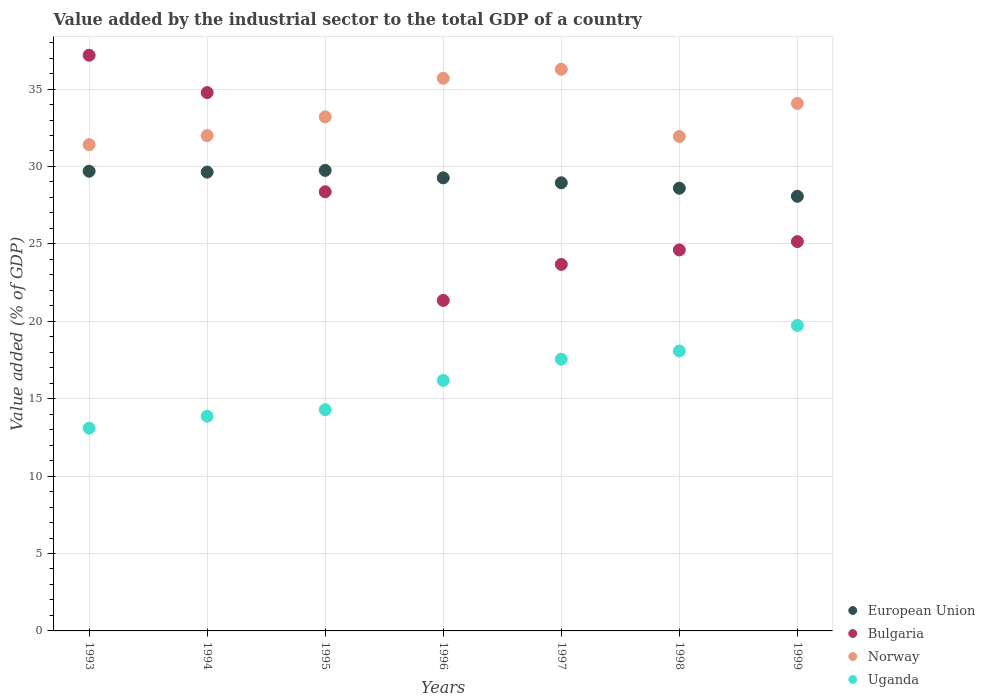What is the value added by the industrial sector to the total GDP in Bulgaria in 1993?
Your answer should be very brief. 37.18. Across all years, what is the maximum value added by the industrial sector to the total GDP in Uganda?
Your response must be concise. 19.73. Across all years, what is the minimum value added by the industrial sector to the total GDP in Bulgaria?
Offer a very short reply. 21.35. In which year was the value added by the industrial sector to the total GDP in Norway maximum?
Your answer should be very brief. 1997. In which year was the value added by the industrial sector to the total GDP in Uganda minimum?
Your answer should be very brief. 1993. What is the total value added by the industrial sector to the total GDP in Norway in the graph?
Your response must be concise. 234.59. What is the difference between the value added by the industrial sector to the total GDP in Norway in 1997 and that in 1999?
Offer a terse response. 2.21. What is the difference between the value added by the industrial sector to the total GDP in Bulgaria in 1998 and the value added by the industrial sector to the total GDP in Norway in 1995?
Provide a succinct answer. -8.6. What is the average value added by the industrial sector to the total GDP in European Union per year?
Your answer should be very brief. 29.14. In the year 1994, what is the difference between the value added by the industrial sector to the total GDP in Bulgaria and value added by the industrial sector to the total GDP in European Union?
Your answer should be compact. 5.14. In how many years, is the value added by the industrial sector to the total GDP in Uganda greater than 29 %?
Ensure brevity in your answer.  0. What is the ratio of the value added by the industrial sector to the total GDP in European Union in 1998 to that in 1999?
Ensure brevity in your answer.  1.02. Is the difference between the value added by the industrial sector to the total GDP in Bulgaria in 1993 and 1994 greater than the difference between the value added by the industrial sector to the total GDP in European Union in 1993 and 1994?
Provide a short and direct response. Yes. What is the difference between the highest and the second highest value added by the industrial sector to the total GDP in Bulgaria?
Your answer should be very brief. 2.41. What is the difference between the highest and the lowest value added by the industrial sector to the total GDP in European Union?
Make the answer very short. 1.67. In how many years, is the value added by the industrial sector to the total GDP in Norway greater than the average value added by the industrial sector to the total GDP in Norway taken over all years?
Your answer should be very brief. 3. Is the sum of the value added by the industrial sector to the total GDP in Norway in 1996 and 1998 greater than the maximum value added by the industrial sector to the total GDP in Bulgaria across all years?
Offer a terse response. Yes. Does the value added by the industrial sector to the total GDP in European Union monotonically increase over the years?
Your answer should be compact. No. Is the value added by the industrial sector to the total GDP in Norway strictly greater than the value added by the industrial sector to the total GDP in European Union over the years?
Keep it short and to the point. Yes. Is the value added by the industrial sector to the total GDP in European Union strictly less than the value added by the industrial sector to the total GDP in Uganda over the years?
Your response must be concise. No. How many dotlines are there?
Offer a very short reply. 4. How many years are there in the graph?
Keep it short and to the point. 7. What is the difference between two consecutive major ticks on the Y-axis?
Keep it short and to the point. 5. Does the graph contain any zero values?
Offer a very short reply. No. Where does the legend appear in the graph?
Offer a very short reply. Bottom right. What is the title of the graph?
Your response must be concise. Value added by the industrial sector to the total GDP of a country. Does "Montenegro" appear as one of the legend labels in the graph?
Your answer should be compact. No. What is the label or title of the Y-axis?
Your response must be concise. Value added (% of GDP). What is the Value added (% of GDP) in European Union in 1993?
Offer a terse response. 29.69. What is the Value added (% of GDP) of Bulgaria in 1993?
Keep it short and to the point. 37.18. What is the Value added (% of GDP) in Norway in 1993?
Offer a very short reply. 31.41. What is the Value added (% of GDP) in Uganda in 1993?
Provide a succinct answer. 13.09. What is the Value added (% of GDP) in European Union in 1994?
Ensure brevity in your answer.  29.64. What is the Value added (% of GDP) of Bulgaria in 1994?
Offer a terse response. 34.77. What is the Value added (% of GDP) of Norway in 1994?
Make the answer very short. 31.99. What is the Value added (% of GDP) of Uganda in 1994?
Offer a very short reply. 13.87. What is the Value added (% of GDP) in European Union in 1995?
Provide a short and direct response. 29.75. What is the Value added (% of GDP) of Bulgaria in 1995?
Provide a succinct answer. 28.37. What is the Value added (% of GDP) of Norway in 1995?
Ensure brevity in your answer.  33.2. What is the Value added (% of GDP) of Uganda in 1995?
Keep it short and to the point. 14.29. What is the Value added (% of GDP) of European Union in 1996?
Your answer should be very brief. 29.26. What is the Value added (% of GDP) in Bulgaria in 1996?
Ensure brevity in your answer.  21.35. What is the Value added (% of GDP) of Norway in 1996?
Your answer should be very brief. 35.7. What is the Value added (% of GDP) in Uganda in 1996?
Your answer should be very brief. 16.18. What is the Value added (% of GDP) in European Union in 1997?
Ensure brevity in your answer.  28.94. What is the Value added (% of GDP) in Bulgaria in 1997?
Your answer should be very brief. 23.67. What is the Value added (% of GDP) of Norway in 1997?
Your answer should be compact. 36.28. What is the Value added (% of GDP) of Uganda in 1997?
Your answer should be compact. 17.55. What is the Value added (% of GDP) in European Union in 1998?
Make the answer very short. 28.6. What is the Value added (% of GDP) of Bulgaria in 1998?
Ensure brevity in your answer.  24.61. What is the Value added (% of GDP) in Norway in 1998?
Offer a terse response. 31.94. What is the Value added (% of GDP) of Uganda in 1998?
Provide a short and direct response. 18.08. What is the Value added (% of GDP) of European Union in 1999?
Keep it short and to the point. 28.07. What is the Value added (% of GDP) of Bulgaria in 1999?
Your answer should be very brief. 25.15. What is the Value added (% of GDP) in Norway in 1999?
Keep it short and to the point. 34.07. What is the Value added (% of GDP) of Uganda in 1999?
Your response must be concise. 19.73. Across all years, what is the maximum Value added (% of GDP) in European Union?
Offer a very short reply. 29.75. Across all years, what is the maximum Value added (% of GDP) in Bulgaria?
Your answer should be compact. 37.18. Across all years, what is the maximum Value added (% of GDP) of Norway?
Provide a succinct answer. 36.28. Across all years, what is the maximum Value added (% of GDP) of Uganda?
Your answer should be compact. 19.73. Across all years, what is the minimum Value added (% of GDP) in European Union?
Keep it short and to the point. 28.07. Across all years, what is the minimum Value added (% of GDP) of Bulgaria?
Your response must be concise. 21.35. Across all years, what is the minimum Value added (% of GDP) in Norway?
Offer a terse response. 31.41. Across all years, what is the minimum Value added (% of GDP) in Uganda?
Provide a succinct answer. 13.09. What is the total Value added (% of GDP) in European Union in the graph?
Your answer should be compact. 203.95. What is the total Value added (% of GDP) in Bulgaria in the graph?
Make the answer very short. 195.09. What is the total Value added (% of GDP) of Norway in the graph?
Your answer should be compact. 234.59. What is the total Value added (% of GDP) in Uganda in the graph?
Keep it short and to the point. 112.79. What is the difference between the Value added (% of GDP) of European Union in 1993 and that in 1994?
Provide a succinct answer. 0.06. What is the difference between the Value added (% of GDP) of Bulgaria in 1993 and that in 1994?
Offer a terse response. 2.41. What is the difference between the Value added (% of GDP) in Norway in 1993 and that in 1994?
Your response must be concise. -0.59. What is the difference between the Value added (% of GDP) of Uganda in 1993 and that in 1994?
Provide a short and direct response. -0.77. What is the difference between the Value added (% of GDP) of European Union in 1993 and that in 1995?
Keep it short and to the point. -0.05. What is the difference between the Value added (% of GDP) of Bulgaria in 1993 and that in 1995?
Make the answer very short. 8.82. What is the difference between the Value added (% of GDP) of Norway in 1993 and that in 1995?
Offer a very short reply. -1.79. What is the difference between the Value added (% of GDP) in Uganda in 1993 and that in 1995?
Your answer should be very brief. -1.2. What is the difference between the Value added (% of GDP) in European Union in 1993 and that in 1996?
Offer a terse response. 0.43. What is the difference between the Value added (% of GDP) of Bulgaria in 1993 and that in 1996?
Provide a short and direct response. 15.84. What is the difference between the Value added (% of GDP) of Norway in 1993 and that in 1996?
Your answer should be very brief. -4.29. What is the difference between the Value added (% of GDP) in Uganda in 1993 and that in 1996?
Provide a succinct answer. -3.09. What is the difference between the Value added (% of GDP) of European Union in 1993 and that in 1997?
Make the answer very short. 0.75. What is the difference between the Value added (% of GDP) in Bulgaria in 1993 and that in 1997?
Keep it short and to the point. 13.51. What is the difference between the Value added (% of GDP) in Norway in 1993 and that in 1997?
Give a very brief answer. -4.87. What is the difference between the Value added (% of GDP) of Uganda in 1993 and that in 1997?
Keep it short and to the point. -4.46. What is the difference between the Value added (% of GDP) of European Union in 1993 and that in 1998?
Offer a very short reply. 1.1. What is the difference between the Value added (% of GDP) in Bulgaria in 1993 and that in 1998?
Provide a short and direct response. 12.58. What is the difference between the Value added (% of GDP) in Norway in 1993 and that in 1998?
Offer a terse response. -0.53. What is the difference between the Value added (% of GDP) of Uganda in 1993 and that in 1998?
Provide a short and direct response. -4.98. What is the difference between the Value added (% of GDP) of European Union in 1993 and that in 1999?
Ensure brevity in your answer.  1.62. What is the difference between the Value added (% of GDP) of Bulgaria in 1993 and that in 1999?
Offer a terse response. 12.04. What is the difference between the Value added (% of GDP) in Norway in 1993 and that in 1999?
Your response must be concise. -2.66. What is the difference between the Value added (% of GDP) of Uganda in 1993 and that in 1999?
Provide a short and direct response. -6.63. What is the difference between the Value added (% of GDP) in European Union in 1994 and that in 1995?
Your answer should be very brief. -0.11. What is the difference between the Value added (% of GDP) of Bulgaria in 1994 and that in 1995?
Keep it short and to the point. 6.41. What is the difference between the Value added (% of GDP) of Norway in 1994 and that in 1995?
Offer a terse response. -1.21. What is the difference between the Value added (% of GDP) in Uganda in 1994 and that in 1995?
Offer a terse response. -0.43. What is the difference between the Value added (% of GDP) of European Union in 1994 and that in 1996?
Provide a succinct answer. 0.37. What is the difference between the Value added (% of GDP) of Bulgaria in 1994 and that in 1996?
Offer a terse response. 13.42. What is the difference between the Value added (% of GDP) of Norway in 1994 and that in 1996?
Keep it short and to the point. -3.7. What is the difference between the Value added (% of GDP) in Uganda in 1994 and that in 1996?
Your response must be concise. -2.31. What is the difference between the Value added (% of GDP) in European Union in 1994 and that in 1997?
Offer a very short reply. 0.69. What is the difference between the Value added (% of GDP) of Bulgaria in 1994 and that in 1997?
Your answer should be compact. 11.1. What is the difference between the Value added (% of GDP) in Norway in 1994 and that in 1997?
Provide a succinct answer. -4.29. What is the difference between the Value added (% of GDP) in Uganda in 1994 and that in 1997?
Ensure brevity in your answer.  -3.69. What is the difference between the Value added (% of GDP) in European Union in 1994 and that in 1998?
Give a very brief answer. 1.04. What is the difference between the Value added (% of GDP) in Bulgaria in 1994 and that in 1998?
Offer a terse response. 10.16. What is the difference between the Value added (% of GDP) in Norway in 1994 and that in 1998?
Make the answer very short. 0.06. What is the difference between the Value added (% of GDP) of Uganda in 1994 and that in 1998?
Provide a succinct answer. -4.21. What is the difference between the Value added (% of GDP) of European Union in 1994 and that in 1999?
Give a very brief answer. 1.56. What is the difference between the Value added (% of GDP) in Bulgaria in 1994 and that in 1999?
Offer a very short reply. 9.63. What is the difference between the Value added (% of GDP) in Norway in 1994 and that in 1999?
Ensure brevity in your answer.  -2.08. What is the difference between the Value added (% of GDP) of Uganda in 1994 and that in 1999?
Your answer should be compact. -5.86. What is the difference between the Value added (% of GDP) of European Union in 1995 and that in 1996?
Give a very brief answer. 0.48. What is the difference between the Value added (% of GDP) of Bulgaria in 1995 and that in 1996?
Give a very brief answer. 7.02. What is the difference between the Value added (% of GDP) of Norway in 1995 and that in 1996?
Your answer should be compact. -2.49. What is the difference between the Value added (% of GDP) of Uganda in 1995 and that in 1996?
Give a very brief answer. -1.89. What is the difference between the Value added (% of GDP) in European Union in 1995 and that in 1997?
Your answer should be compact. 0.8. What is the difference between the Value added (% of GDP) of Bulgaria in 1995 and that in 1997?
Your response must be concise. 4.69. What is the difference between the Value added (% of GDP) in Norway in 1995 and that in 1997?
Offer a very short reply. -3.08. What is the difference between the Value added (% of GDP) of Uganda in 1995 and that in 1997?
Provide a succinct answer. -3.26. What is the difference between the Value added (% of GDP) of European Union in 1995 and that in 1998?
Make the answer very short. 1.15. What is the difference between the Value added (% of GDP) of Bulgaria in 1995 and that in 1998?
Provide a short and direct response. 3.76. What is the difference between the Value added (% of GDP) of Norway in 1995 and that in 1998?
Your answer should be compact. 1.27. What is the difference between the Value added (% of GDP) of Uganda in 1995 and that in 1998?
Your answer should be compact. -3.79. What is the difference between the Value added (% of GDP) in European Union in 1995 and that in 1999?
Your answer should be very brief. 1.67. What is the difference between the Value added (% of GDP) of Bulgaria in 1995 and that in 1999?
Offer a terse response. 3.22. What is the difference between the Value added (% of GDP) of Norway in 1995 and that in 1999?
Offer a very short reply. -0.87. What is the difference between the Value added (% of GDP) of Uganda in 1995 and that in 1999?
Your answer should be very brief. -5.44. What is the difference between the Value added (% of GDP) of European Union in 1996 and that in 1997?
Offer a very short reply. 0.32. What is the difference between the Value added (% of GDP) of Bulgaria in 1996 and that in 1997?
Offer a terse response. -2.32. What is the difference between the Value added (% of GDP) in Norway in 1996 and that in 1997?
Offer a very short reply. -0.58. What is the difference between the Value added (% of GDP) of Uganda in 1996 and that in 1997?
Give a very brief answer. -1.37. What is the difference between the Value added (% of GDP) in European Union in 1996 and that in 1998?
Your response must be concise. 0.67. What is the difference between the Value added (% of GDP) in Bulgaria in 1996 and that in 1998?
Provide a short and direct response. -3.26. What is the difference between the Value added (% of GDP) of Norway in 1996 and that in 1998?
Keep it short and to the point. 3.76. What is the difference between the Value added (% of GDP) in Uganda in 1996 and that in 1998?
Give a very brief answer. -1.9. What is the difference between the Value added (% of GDP) of European Union in 1996 and that in 1999?
Provide a succinct answer. 1.19. What is the difference between the Value added (% of GDP) of Bulgaria in 1996 and that in 1999?
Provide a short and direct response. -3.8. What is the difference between the Value added (% of GDP) of Norway in 1996 and that in 1999?
Ensure brevity in your answer.  1.62. What is the difference between the Value added (% of GDP) in Uganda in 1996 and that in 1999?
Make the answer very short. -3.55. What is the difference between the Value added (% of GDP) in European Union in 1997 and that in 1998?
Provide a succinct answer. 0.35. What is the difference between the Value added (% of GDP) in Bulgaria in 1997 and that in 1998?
Give a very brief answer. -0.94. What is the difference between the Value added (% of GDP) in Norway in 1997 and that in 1998?
Your response must be concise. 4.34. What is the difference between the Value added (% of GDP) of Uganda in 1997 and that in 1998?
Give a very brief answer. -0.53. What is the difference between the Value added (% of GDP) of European Union in 1997 and that in 1999?
Offer a very short reply. 0.87. What is the difference between the Value added (% of GDP) of Bulgaria in 1997 and that in 1999?
Offer a terse response. -1.48. What is the difference between the Value added (% of GDP) in Norway in 1997 and that in 1999?
Ensure brevity in your answer.  2.21. What is the difference between the Value added (% of GDP) of Uganda in 1997 and that in 1999?
Your answer should be compact. -2.18. What is the difference between the Value added (% of GDP) of European Union in 1998 and that in 1999?
Offer a terse response. 0.52. What is the difference between the Value added (% of GDP) in Bulgaria in 1998 and that in 1999?
Your answer should be compact. -0.54. What is the difference between the Value added (% of GDP) in Norway in 1998 and that in 1999?
Your response must be concise. -2.14. What is the difference between the Value added (% of GDP) in Uganda in 1998 and that in 1999?
Ensure brevity in your answer.  -1.65. What is the difference between the Value added (% of GDP) in European Union in 1993 and the Value added (% of GDP) in Bulgaria in 1994?
Offer a terse response. -5.08. What is the difference between the Value added (% of GDP) of European Union in 1993 and the Value added (% of GDP) of Norway in 1994?
Make the answer very short. -2.3. What is the difference between the Value added (% of GDP) in European Union in 1993 and the Value added (% of GDP) in Uganda in 1994?
Provide a succinct answer. 15.83. What is the difference between the Value added (% of GDP) in Bulgaria in 1993 and the Value added (% of GDP) in Norway in 1994?
Provide a short and direct response. 5.19. What is the difference between the Value added (% of GDP) in Bulgaria in 1993 and the Value added (% of GDP) in Uganda in 1994?
Keep it short and to the point. 23.32. What is the difference between the Value added (% of GDP) in Norway in 1993 and the Value added (% of GDP) in Uganda in 1994?
Keep it short and to the point. 17.54. What is the difference between the Value added (% of GDP) of European Union in 1993 and the Value added (% of GDP) of Bulgaria in 1995?
Offer a very short reply. 1.33. What is the difference between the Value added (% of GDP) in European Union in 1993 and the Value added (% of GDP) in Norway in 1995?
Your answer should be compact. -3.51. What is the difference between the Value added (% of GDP) in European Union in 1993 and the Value added (% of GDP) in Uganda in 1995?
Your answer should be very brief. 15.4. What is the difference between the Value added (% of GDP) of Bulgaria in 1993 and the Value added (% of GDP) of Norway in 1995?
Your answer should be compact. 3.98. What is the difference between the Value added (% of GDP) in Bulgaria in 1993 and the Value added (% of GDP) in Uganda in 1995?
Keep it short and to the point. 22.89. What is the difference between the Value added (% of GDP) of Norway in 1993 and the Value added (% of GDP) of Uganda in 1995?
Ensure brevity in your answer.  17.12. What is the difference between the Value added (% of GDP) in European Union in 1993 and the Value added (% of GDP) in Bulgaria in 1996?
Your answer should be very brief. 8.35. What is the difference between the Value added (% of GDP) of European Union in 1993 and the Value added (% of GDP) of Norway in 1996?
Offer a terse response. -6. What is the difference between the Value added (% of GDP) in European Union in 1993 and the Value added (% of GDP) in Uganda in 1996?
Offer a terse response. 13.51. What is the difference between the Value added (% of GDP) of Bulgaria in 1993 and the Value added (% of GDP) of Norway in 1996?
Ensure brevity in your answer.  1.49. What is the difference between the Value added (% of GDP) in Bulgaria in 1993 and the Value added (% of GDP) in Uganda in 1996?
Your answer should be very brief. 21. What is the difference between the Value added (% of GDP) in Norway in 1993 and the Value added (% of GDP) in Uganda in 1996?
Your answer should be very brief. 15.23. What is the difference between the Value added (% of GDP) in European Union in 1993 and the Value added (% of GDP) in Bulgaria in 1997?
Provide a succinct answer. 6.02. What is the difference between the Value added (% of GDP) in European Union in 1993 and the Value added (% of GDP) in Norway in 1997?
Provide a short and direct response. -6.59. What is the difference between the Value added (% of GDP) in European Union in 1993 and the Value added (% of GDP) in Uganda in 1997?
Give a very brief answer. 12.14. What is the difference between the Value added (% of GDP) in Bulgaria in 1993 and the Value added (% of GDP) in Norway in 1997?
Your response must be concise. 0.9. What is the difference between the Value added (% of GDP) of Bulgaria in 1993 and the Value added (% of GDP) of Uganda in 1997?
Your response must be concise. 19.63. What is the difference between the Value added (% of GDP) in Norway in 1993 and the Value added (% of GDP) in Uganda in 1997?
Make the answer very short. 13.86. What is the difference between the Value added (% of GDP) of European Union in 1993 and the Value added (% of GDP) of Bulgaria in 1998?
Keep it short and to the point. 5.09. What is the difference between the Value added (% of GDP) of European Union in 1993 and the Value added (% of GDP) of Norway in 1998?
Your answer should be very brief. -2.24. What is the difference between the Value added (% of GDP) in European Union in 1993 and the Value added (% of GDP) in Uganda in 1998?
Your answer should be very brief. 11.61. What is the difference between the Value added (% of GDP) of Bulgaria in 1993 and the Value added (% of GDP) of Norway in 1998?
Your answer should be very brief. 5.25. What is the difference between the Value added (% of GDP) in Bulgaria in 1993 and the Value added (% of GDP) in Uganda in 1998?
Your answer should be compact. 19.1. What is the difference between the Value added (% of GDP) in Norway in 1993 and the Value added (% of GDP) in Uganda in 1998?
Provide a short and direct response. 13.33. What is the difference between the Value added (% of GDP) of European Union in 1993 and the Value added (% of GDP) of Bulgaria in 1999?
Your answer should be very brief. 4.55. What is the difference between the Value added (% of GDP) in European Union in 1993 and the Value added (% of GDP) in Norway in 1999?
Ensure brevity in your answer.  -4.38. What is the difference between the Value added (% of GDP) in European Union in 1993 and the Value added (% of GDP) in Uganda in 1999?
Your answer should be compact. 9.96. What is the difference between the Value added (% of GDP) in Bulgaria in 1993 and the Value added (% of GDP) in Norway in 1999?
Keep it short and to the point. 3.11. What is the difference between the Value added (% of GDP) of Bulgaria in 1993 and the Value added (% of GDP) of Uganda in 1999?
Your answer should be very brief. 17.45. What is the difference between the Value added (% of GDP) in Norway in 1993 and the Value added (% of GDP) in Uganda in 1999?
Offer a terse response. 11.68. What is the difference between the Value added (% of GDP) of European Union in 1994 and the Value added (% of GDP) of Bulgaria in 1995?
Make the answer very short. 1.27. What is the difference between the Value added (% of GDP) of European Union in 1994 and the Value added (% of GDP) of Norway in 1995?
Offer a very short reply. -3.57. What is the difference between the Value added (% of GDP) in European Union in 1994 and the Value added (% of GDP) in Uganda in 1995?
Your answer should be very brief. 15.34. What is the difference between the Value added (% of GDP) in Bulgaria in 1994 and the Value added (% of GDP) in Norway in 1995?
Your response must be concise. 1.57. What is the difference between the Value added (% of GDP) in Bulgaria in 1994 and the Value added (% of GDP) in Uganda in 1995?
Offer a terse response. 20.48. What is the difference between the Value added (% of GDP) in Norway in 1994 and the Value added (% of GDP) in Uganda in 1995?
Your answer should be compact. 17.7. What is the difference between the Value added (% of GDP) of European Union in 1994 and the Value added (% of GDP) of Bulgaria in 1996?
Ensure brevity in your answer.  8.29. What is the difference between the Value added (% of GDP) in European Union in 1994 and the Value added (% of GDP) in Norway in 1996?
Make the answer very short. -6.06. What is the difference between the Value added (% of GDP) in European Union in 1994 and the Value added (% of GDP) in Uganda in 1996?
Provide a succinct answer. 13.46. What is the difference between the Value added (% of GDP) in Bulgaria in 1994 and the Value added (% of GDP) in Norway in 1996?
Provide a succinct answer. -0.92. What is the difference between the Value added (% of GDP) of Bulgaria in 1994 and the Value added (% of GDP) of Uganda in 1996?
Ensure brevity in your answer.  18.59. What is the difference between the Value added (% of GDP) in Norway in 1994 and the Value added (% of GDP) in Uganda in 1996?
Offer a very short reply. 15.81. What is the difference between the Value added (% of GDP) of European Union in 1994 and the Value added (% of GDP) of Bulgaria in 1997?
Provide a succinct answer. 5.96. What is the difference between the Value added (% of GDP) in European Union in 1994 and the Value added (% of GDP) in Norway in 1997?
Offer a very short reply. -6.64. What is the difference between the Value added (% of GDP) of European Union in 1994 and the Value added (% of GDP) of Uganda in 1997?
Make the answer very short. 12.08. What is the difference between the Value added (% of GDP) of Bulgaria in 1994 and the Value added (% of GDP) of Norway in 1997?
Keep it short and to the point. -1.51. What is the difference between the Value added (% of GDP) in Bulgaria in 1994 and the Value added (% of GDP) in Uganda in 1997?
Your answer should be compact. 17.22. What is the difference between the Value added (% of GDP) in Norway in 1994 and the Value added (% of GDP) in Uganda in 1997?
Provide a short and direct response. 14.44. What is the difference between the Value added (% of GDP) in European Union in 1994 and the Value added (% of GDP) in Bulgaria in 1998?
Keep it short and to the point. 5.03. What is the difference between the Value added (% of GDP) of European Union in 1994 and the Value added (% of GDP) of Norway in 1998?
Ensure brevity in your answer.  -2.3. What is the difference between the Value added (% of GDP) in European Union in 1994 and the Value added (% of GDP) in Uganda in 1998?
Your response must be concise. 11.56. What is the difference between the Value added (% of GDP) of Bulgaria in 1994 and the Value added (% of GDP) of Norway in 1998?
Your answer should be compact. 2.84. What is the difference between the Value added (% of GDP) of Bulgaria in 1994 and the Value added (% of GDP) of Uganda in 1998?
Your answer should be compact. 16.69. What is the difference between the Value added (% of GDP) of Norway in 1994 and the Value added (% of GDP) of Uganda in 1998?
Provide a short and direct response. 13.91. What is the difference between the Value added (% of GDP) of European Union in 1994 and the Value added (% of GDP) of Bulgaria in 1999?
Keep it short and to the point. 4.49. What is the difference between the Value added (% of GDP) in European Union in 1994 and the Value added (% of GDP) in Norway in 1999?
Make the answer very short. -4.43. What is the difference between the Value added (% of GDP) in European Union in 1994 and the Value added (% of GDP) in Uganda in 1999?
Provide a succinct answer. 9.91. What is the difference between the Value added (% of GDP) of Bulgaria in 1994 and the Value added (% of GDP) of Norway in 1999?
Your answer should be very brief. 0.7. What is the difference between the Value added (% of GDP) of Bulgaria in 1994 and the Value added (% of GDP) of Uganda in 1999?
Offer a terse response. 15.04. What is the difference between the Value added (% of GDP) of Norway in 1994 and the Value added (% of GDP) of Uganda in 1999?
Provide a short and direct response. 12.26. What is the difference between the Value added (% of GDP) in European Union in 1995 and the Value added (% of GDP) in Bulgaria in 1996?
Offer a terse response. 8.4. What is the difference between the Value added (% of GDP) of European Union in 1995 and the Value added (% of GDP) of Norway in 1996?
Ensure brevity in your answer.  -5.95. What is the difference between the Value added (% of GDP) in European Union in 1995 and the Value added (% of GDP) in Uganda in 1996?
Ensure brevity in your answer.  13.56. What is the difference between the Value added (% of GDP) in Bulgaria in 1995 and the Value added (% of GDP) in Norway in 1996?
Keep it short and to the point. -7.33. What is the difference between the Value added (% of GDP) in Bulgaria in 1995 and the Value added (% of GDP) in Uganda in 1996?
Offer a terse response. 12.18. What is the difference between the Value added (% of GDP) in Norway in 1995 and the Value added (% of GDP) in Uganda in 1996?
Provide a succinct answer. 17.02. What is the difference between the Value added (% of GDP) of European Union in 1995 and the Value added (% of GDP) of Bulgaria in 1997?
Provide a short and direct response. 6.07. What is the difference between the Value added (% of GDP) in European Union in 1995 and the Value added (% of GDP) in Norway in 1997?
Your response must be concise. -6.54. What is the difference between the Value added (% of GDP) of European Union in 1995 and the Value added (% of GDP) of Uganda in 1997?
Give a very brief answer. 12.19. What is the difference between the Value added (% of GDP) in Bulgaria in 1995 and the Value added (% of GDP) in Norway in 1997?
Keep it short and to the point. -7.92. What is the difference between the Value added (% of GDP) of Bulgaria in 1995 and the Value added (% of GDP) of Uganda in 1997?
Your answer should be compact. 10.81. What is the difference between the Value added (% of GDP) of Norway in 1995 and the Value added (% of GDP) of Uganda in 1997?
Ensure brevity in your answer.  15.65. What is the difference between the Value added (% of GDP) in European Union in 1995 and the Value added (% of GDP) in Bulgaria in 1998?
Offer a very short reply. 5.14. What is the difference between the Value added (% of GDP) of European Union in 1995 and the Value added (% of GDP) of Norway in 1998?
Keep it short and to the point. -2.19. What is the difference between the Value added (% of GDP) of European Union in 1995 and the Value added (% of GDP) of Uganda in 1998?
Keep it short and to the point. 11.67. What is the difference between the Value added (% of GDP) in Bulgaria in 1995 and the Value added (% of GDP) in Norway in 1998?
Ensure brevity in your answer.  -3.57. What is the difference between the Value added (% of GDP) of Bulgaria in 1995 and the Value added (% of GDP) of Uganda in 1998?
Provide a short and direct response. 10.29. What is the difference between the Value added (% of GDP) in Norway in 1995 and the Value added (% of GDP) in Uganda in 1998?
Your answer should be very brief. 15.12. What is the difference between the Value added (% of GDP) in European Union in 1995 and the Value added (% of GDP) in Bulgaria in 1999?
Provide a short and direct response. 4.6. What is the difference between the Value added (% of GDP) in European Union in 1995 and the Value added (% of GDP) in Norway in 1999?
Offer a very short reply. -4.33. What is the difference between the Value added (% of GDP) in European Union in 1995 and the Value added (% of GDP) in Uganda in 1999?
Make the answer very short. 10.02. What is the difference between the Value added (% of GDP) of Bulgaria in 1995 and the Value added (% of GDP) of Norway in 1999?
Give a very brief answer. -5.71. What is the difference between the Value added (% of GDP) of Bulgaria in 1995 and the Value added (% of GDP) of Uganda in 1999?
Give a very brief answer. 8.64. What is the difference between the Value added (% of GDP) in Norway in 1995 and the Value added (% of GDP) in Uganda in 1999?
Offer a terse response. 13.47. What is the difference between the Value added (% of GDP) in European Union in 1996 and the Value added (% of GDP) in Bulgaria in 1997?
Provide a succinct answer. 5.59. What is the difference between the Value added (% of GDP) in European Union in 1996 and the Value added (% of GDP) in Norway in 1997?
Provide a succinct answer. -7.02. What is the difference between the Value added (% of GDP) in European Union in 1996 and the Value added (% of GDP) in Uganda in 1997?
Your answer should be very brief. 11.71. What is the difference between the Value added (% of GDP) in Bulgaria in 1996 and the Value added (% of GDP) in Norway in 1997?
Your answer should be compact. -14.93. What is the difference between the Value added (% of GDP) in Bulgaria in 1996 and the Value added (% of GDP) in Uganda in 1997?
Your answer should be very brief. 3.8. What is the difference between the Value added (% of GDP) of Norway in 1996 and the Value added (% of GDP) of Uganda in 1997?
Your answer should be compact. 18.14. What is the difference between the Value added (% of GDP) in European Union in 1996 and the Value added (% of GDP) in Bulgaria in 1998?
Provide a succinct answer. 4.66. What is the difference between the Value added (% of GDP) of European Union in 1996 and the Value added (% of GDP) of Norway in 1998?
Your response must be concise. -2.67. What is the difference between the Value added (% of GDP) in European Union in 1996 and the Value added (% of GDP) in Uganda in 1998?
Your answer should be compact. 11.18. What is the difference between the Value added (% of GDP) of Bulgaria in 1996 and the Value added (% of GDP) of Norway in 1998?
Keep it short and to the point. -10.59. What is the difference between the Value added (% of GDP) of Bulgaria in 1996 and the Value added (% of GDP) of Uganda in 1998?
Make the answer very short. 3.27. What is the difference between the Value added (% of GDP) in Norway in 1996 and the Value added (% of GDP) in Uganda in 1998?
Ensure brevity in your answer.  17.62. What is the difference between the Value added (% of GDP) in European Union in 1996 and the Value added (% of GDP) in Bulgaria in 1999?
Give a very brief answer. 4.12. What is the difference between the Value added (% of GDP) in European Union in 1996 and the Value added (% of GDP) in Norway in 1999?
Your answer should be compact. -4.81. What is the difference between the Value added (% of GDP) in European Union in 1996 and the Value added (% of GDP) in Uganda in 1999?
Make the answer very short. 9.53. What is the difference between the Value added (% of GDP) of Bulgaria in 1996 and the Value added (% of GDP) of Norway in 1999?
Your answer should be very brief. -12.72. What is the difference between the Value added (% of GDP) in Bulgaria in 1996 and the Value added (% of GDP) in Uganda in 1999?
Provide a short and direct response. 1.62. What is the difference between the Value added (% of GDP) of Norway in 1996 and the Value added (% of GDP) of Uganda in 1999?
Your answer should be very brief. 15.97. What is the difference between the Value added (% of GDP) in European Union in 1997 and the Value added (% of GDP) in Bulgaria in 1998?
Your answer should be very brief. 4.34. What is the difference between the Value added (% of GDP) in European Union in 1997 and the Value added (% of GDP) in Norway in 1998?
Ensure brevity in your answer.  -2.99. What is the difference between the Value added (% of GDP) in European Union in 1997 and the Value added (% of GDP) in Uganda in 1998?
Keep it short and to the point. 10.87. What is the difference between the Value added (% of GDP) in Bulgaria in 1997 and the Value added (% of GDP) in Norway in 1998?
Offer a terse response. -8.26. What is the difference between the Value added (% of GDP) in Bulgaria in 1997 and the Value added (% of GDP) in Uganda in 1998?
Provide a short and direct response. 5.59. What is the difference between the Value added (% of GDP) of Norway in 1997 and the Value added (% of GDP) of Uganda in 1998?
Your answer should be compact. 18.2. What is the difference between the Value added (% of GDP) of European Union in 1997 and the Value added (% of GDP) of Bulgaria in 1999?
Provide a short and direct response. 3.8. What is the difference between the Value added (% of GDP) in European Union in 1997 and the Value added (% of GDP) in Norway in 1999?
Give a very brief answer. -5.13. What is the difference between the Value added (% of GDP) in European Union in 1997 and the Value added (% of GDP) in Uganda in 1999?
Provide a short and direct response. 9.21. What is the difference between the Value added (% of GDP) of Bulgaria in 1997 and the Value added (% of GDP) of Norway in 1999?
Ensure brevity in your answer.  -10.4. What is the difference between the Value added (% of GDP) of Bulgaria in 1997 and the Value added (% of GDP) of Uganda in 1999?
Your answer should be compact. 3.94. What is the difference between the Value added (% of GDP) of Norway in 1997 and the Value added (% of GDP) of Uganda in 1999?
Give a very brief answer. 16.55. What is the difference between the Value added (% of GDP) of European Union in 1998 and the Value added (% of GDP) of Bulgaria in 1999?
Provide a short and direct response. 3.45. What is the difference between the Value added (% of GDP) of European Union in 1998 and the Value added (% of GDP) of Norway in 1999?
Your answer should be very brief. -5.48. What is the difference between the Value added (% of GDP) of European Union in 1998 and the Value added (% of GDP) of Uganda in 1999?
Provide a short and direct response. 8.87. What is the difference between the Value added (% of GDP) of Bulgaria in 1998 and the Value added (% of GDP) of Norway in 1999?
Ensure brevity in your answer.  -9.46. What is the difference between the Value added (% of GDP) in Bulgaria in 1998 and the Value added (% of GDP) in Uganda in 1999?
Provide a succinct answer. 4.88. What is the difference between the Value added (% of GDP) of Norway in 1998 and the Value added (% of GDP) of Uganda in 1999?
Offer a terse response. 12.21. What is the average Value added (% of GDP) of European Union per year?
Make the answer very short. 29.14. What is the average Value added (% of GDP) of Bulgaria per year?
Offer a terse response. 27.87. What is the average Value added (% of GDP) of Norway per year?
Provide a succinct answer. 33.51. What is the average Value added (% of GDP) in Uganda per year?
Your answer should be compact. 16.11. In the year 1993, what is the difference between the Value added (% of GDP) in European Union and Value added (% of GDP) in Bulgaria?
Provide a succinct answer. -7.49. In the year 1993, what is the difference between the Value added (% of GDP) in European Union and Value added (% of GDP) in Norway?
Offer a very short reply. -1.72. In the year 1993, what is the difference between the Value added (% of GDP) in European Union and Value added (% of GDP) in Uganda?
Keep it short and to the point. 16.6. In the year 1993, what is the difference between the Value added (% of GDP) of Bulgaria and Value added (% of GDP) of Norway?
Provide a short and direct response. 5.78. In the year 1993, what is the difference between the Value added (% of GDP) in Bulgaria and Value added (% of GDP) in Uganda?
Offer a terse response. 24.09. In the year 1993, what is the difference between the Value added (% of GDP) in Norway and Value added (% of GDP) in Uganda?
Your response must be concise. 18.31. In the year 1994, what is the difference between the Value added (% of GDP) of European Union and Value added (% of GDP) of Bulgaria?
Your answer should be compact. -5.14. In the year 1994, what is the difference between the Value added (% of GDP) of European Union and Value added (% of GDP) of Norway?
Keep it short and to the point. -2.36. In the year 1994, what is the difference between the Value added (% of GDP) in European Union and Value added (% of GDP) in Uganda?
Offer a terse response. 15.77. In the year 1994, what is the difference between the Value added (% of GDP) in Bulgaria and Value added (% of GDP) in Norway?
Make the answer very short. 2.78. In the year 1994, what is the difference between the Value added (% of GDP) of Bulgaria and Value added (% of GDP) of Uganda?
Make the answer very short. 20.91. In the year 1994, what is the difference between the Value added (% of GDP) in Norway and Value added (% of GDP) in Uganda?
Your response must be concise. 18.13. In the year 1995, what is the difference between the Value added (% of GDP) in European Union and Value added (% of GDP) in Bulgaria?
Your response must be concise. 1.38. In the year 1995, what is the difference between the Value added (% of GDP) in European Union and Value added (% of GDP) in Norway?
Offer a terse response. -3.46. In the year 1995, what is the difference between the Value added (% of GDP) in European Union and Value added (% of GDP) in Uganda?
Offer a very short reply. 15.45. In the year 1995, what is the difference between the Value added (% of GDP) of Bulgaria and Value added (% of GDP) of Norway?
Provide a short and direct response. -4.84. In the year 1995, what is the difference between the Value added (% of GDP) of Bulgaria and Value added (% of GDP) of Uganda?
Ensure brevity in your answer.  14.07. In the year 1995, what is the difference between the Value added (% of GDP) of Norway and Value added (% of GDP) of Uganda?
Provide a short and direct response. 18.91. In the year 1996, what is the difference between the Value added (% of GDP) in European Union and Value added (% of GDP) in Bulgaria?
Ensure brevity in your answer.  7.92. In the year 1996, what is the difference between the Value added (% of GDP) of European Union and Value added (% of GDP) of Norway?
Offer a very short reply. -6.43. In the year 1996, what is the difference between the Value added (% of GDP) in European Union and Value added (% of GDP) in Uganda?
Offer a terse response. 13.08. In the year 1996, what is the difference between the Value added (% of GDP) of Bulgaria and Value added (% of GDP) of Norway?
Your answer should be very brief. -14.35. In the year 1996, what is the difference between the Value added (% of GDP) of Bulgaria and Value added (% of GDP) of Uganda?
Provide a short and direct response. 5.17. In the year 1996, what is the difference between the Value added (% of GDP) in Norway and Value added (% of GDP) in Uganda?
Provide a succinct answer. 19.51. In the year 1997, what is the difference between the Value added (% of GDP) of European Union and Value added (% of GDP) of Bulgaria?
Provide a short and direct response. 5.27. In the year 1997, what is the difference between the Value added (% of GDP) in European Union and Value added (% of GDP) in Norway?
Offer a very short reply. -7.34. In the year 1997, what is the difference between the Value added (% of GDP) of European Union and Value added (% of GDP) of Uganda?
Give a very brief answer. 11.39. In the year 1997, what is the difference between the Value added (% of GDP) in Bulgaria and Value added (% of GDP) in Norway?
Offer a very short reply. -12.61. In the year 1997, what is the difference between the Value added (% of GDP) in Bulgaria and Value added (% of GDP) in Uganda?
Provide a short and direct response. 6.12. In the year 1997, what is the difference between the Value added (% of GDP) in Norway and Value added (% of GDP) in Uganda?
Make the answer very short. 18.73. In the year 1998, what is the difference between the Value added (% of GDP) of European Union and Value added (% of GDP) of Bulgaria?
Your answer should be compact. 3.99. In the year 1998, what is the difference between the Value added (% of GDP) of European Union and Value added (% of GDP) of Norway?
Your response must be concise. -3.34. In the year 1998, what is the difference between the Value added (% of GDP) in European Union and Value added (% of GDP) in Uganda?
Make the answer very short. 10.52. In the year 1998, what is the difference between the Value added (% of GDP) of Bulgaria and Value added (% of GDP) of Norway?
Your response must be concise. -7.33. In the year 1998, what is the difference between the Value added (% of GDP) in Bulgaria and Value added (% of GDP) in Uganda?
Give a very brief answer. 6.53. In the year 1998, what is the difference between the Value added (% of GDP) in Norway and Value added (% of GDP) in Uganda?
Offer a terse response. 13.86. In the year 1999, what is the difference between the Value added (% of GDP) of European Union and Value added (% of GDP) of Bulgaria?
Offer a very short reply. 2.93. In the year 1999, what is the difference between the Value added (% of GDP) in European Union and Value added (% of GDP) in Norway?
Keep it short and to the point. -6. In the year 1999, what is the difference between the Value added (% of GDP) of European Union and Value added (% of GDP) of Uganda?
Keep it short and to the point. 8.34. In the year 1999, what is the difference between the Value added (% of GDP) in Bulgaria and Value added (% of GDP) in Norway?
Ensure brevity in your answer.  -8.92. In the year 1999, what is the difference between the Value added (% of GDP) in Bulgaria and Value added (% of GDP) in Uganda?
Make the answer very short. 5.42. In the year 1999, what is the difference between the Value added (% of GDP) in Norway and Value added (% of GDP) in Uganda?
Your answer should be very brief. 14.34. What is the ratio of the Value added (% of GDP) of European Union in 1993 to that in 1994?
Make the answer very short. 1. What is the ratio of the Value added (% of GDP) in Bulgaria in 1993 to that in 1994?
Your answer should be compact. 1.07. What is the ratio of the Value added (% of GDP) in Norway in 1993 to that in 1994?
Ensure brevity in your answer.  0.98. What is the ratio of the Value added (% of GDP) in Uganda in 1993 to that in 1994?
Give a very brief answer. 0.94. What is the ratio of the Value added (% of GDP) in Bulgaria in 1993 to that in 1995?
Your answer should be very brief. 1.31. What is the ratio of the Value added (% of GDP) of Norway in 1993 to that in 1995?
Offer a very short reply. 0.95. What is the ratio of the Value added (% of GDP) in Uganda in 1993 to that in 1995?
Give a very brief answer. 0.92. What is the ratio of the Value added (% of GDP) of European Union in 1993 to that in 1996?
Make the answer very short. 1.01. What is the ratio of the Value added (% of GDP) in Bulgaria in 1993 to that in 1996?
Offer a very short reply. 1.74. What is the ratio of the Value added (% of GDP) of Norway in 1993 to that in 1996?
Your answer should be compact. 0.88. What is the ratio of the Value added (% of GDP) in Uganda in 1993 to that in 1996?
Provide a succinct answer. 0.81. What is the ratio of the Value added (% of GDP) in European Union in 1993 to that in 1997?
Your answer should be compact. 1.03. What is the ratio of the Value added (% of GDP) in Bulgaria in 1993 to that in 1997?
Give a very brief answer. 1.57. What is the ratio of the Value added (% of GDP) in Norway in 1993 to that in 1997?
Make the answer very short. 0.87. What is the ratio of the Value added (% of GDP) of Uganda in 1993 to that in 1997?
Your answer should be very brief. 0.75. What is the ratio of the Value added (% of GDP) in European Union in 1993 to that in 1998?
Provide a short and direct response. 1.04. What is the ratio of the Value added (% of GDP) in Bulgaria in 1993 to that in 1998?
Provide a short and direct response. 1.51. What is the ratio of the Value added (% of GDP) of Norway in 1993 to that in 1998?
Ensure brevity in your answer.  0.98. What is the ratio of the Value added (% of GDP) in Uganda in 1993 to that in 1998?
Ensure brevity in your answer.  0.72. What is the ratio of the Value added (% of GDP) in European Union in 1993 to that in 1999?
Offer a very short reply. 1.06. What is the ratio of the Value added (% of GDP) in Bulgaria in 1993 to that in 1999?
Give a very brief answer. 1.48. What is the ratio of the Value added (% of GDP) in Norway in 1993 to that in 1999?
Your response must be concise. 0.92. What is the ratio of the Value added (% of GDP) in Uganda in 1993 to that in 1999?
Your answer should be very brief. 0.66. What is the ratio of the Value added (% of GDP) in Bulgaria in 1994 to that in 1995?
Ensure brevity in your answer.  1.23. What is the ratio of the Value added (% of GDP) in Norway in 1994 to that in 1995?
Make the answer very short. 0.96. What is the ratio of the Value added (% of GDP) in Uganda in 1994 to that in 1995?
Offer a very short reply. 0.97. What is the ratio of the Value added (% of GDP) in European Union in 1994 to that in 1996?
Your response must be concise. 1.01. What is the ratio of the Value added (% of GDP) in Bulgaria in 1994 to that in 1996?
Offer a terse response. 1.63. What is the ratio of the Value added (% of GDP) in Norway in 1994 to that in 1996?
Your answer should be compact. 0.9. What is the ratio of the Value added (% of GDP) of Uganda in 1994 to that in 1996?
Your answer should be very brief. 0.86. What is the ratio of the Value added (% of GDP) in European Union in 1994 to that in 1997?
Provide a short and direct response. 1.02. What is the ratio of the Value added (% of GDP) of Bulgaria in 1994 to that in 1997?
Your answer should be compact. 1.47. What is the ratio of the Value added (% of GDP) in Norway in 1994 to that in 1997?
Keep it short and to the point. 0.88. What is the ratio of the Value added (% of GDP) of Uganda in 1994 to that in 1997?
Ensure brevity in your answer.  0.79. What is the ratio of the Value added (% of GDP) in European Union in 1994 to that in 1998?
Give a very brief answer. 1.04. What is the ratio of the Value added (% of GDP) of Bulgaria in 1994 to that in 1998?
Make the answer very short. 1.41. What is the ratio of the Value added (% of GDP) in Norway in 1994 to that in 1998?
Offer a very short reply. 1. What is the ratio of the Value added (% of GDP) of Uganda in 1994 to that in 1998?
Keep it short and to the point. 0.77. What is the ratio of the Value added (% of GDP) in European Union in 1994 to that in 1999?
Provide a short and direct response. 1.06. What is the ratio of the Value added (% of GDP) of Bulgaria in 1994 to that in 1999?
Offer a very short reply. 1.38. What is the ratio of the Value added (% of GDP) in Norway in 1994 to that in 1999?
Keep it short and to the point. 0.94. What is the ratio of the Value added (% of GDP) of Uganda in 1994 to that in 1999?
Keep it short and to the point. 0.7. What is the ratio of the Value added (% of GDP) of European Union in 1995 to that in 1996?
Offer a terse response. 1.02. What is the ratio of the Value added (% of GDP) in Bulgaria in 1995 to that in 1996?
Your answer should be very brief. 1.33. What is the ratio of the Value added (% of GDP) in Norway in 1995 to that in 1996?
Ensure brevity in your answer.  0.93. What is the ratio of the Value added (% of GDP) in Uganda in 1995 to that in 1996?
Provide a short and direct response. 0.88. What is the ratio of the Value added (% of GDP) of European Union in 1995 to that in 1997?
Offer a very short reply. 1.03. What is the ratio of the Value added (% of GDP) of Bulgaria in 1995 to that in 1997?
Your answer should be compact. 1.2. What is the ratio of the Value added (% of GDP) of Norway in 1995 to that in 1997?
Offer a terse response. 0.92. What is the ratio of the Value added (% of GDP) in Uganda in 1995 to that in 1997?
Offer a very short reply. 0.81. What is the ratio of the Value added (% of GDP) of European Union in 1995 to that in 1998?
Keep it short and to the point. 1.04. What is the ratio of the Value added (% of GDP) in Bulgaria in 1995 to that in 1998?
Make the answer very short. 1.15. What is the ratio of the Value added (% of GDP) in Norway in 1995 to that in 1998?
Ensure brevity in your answer.  1.04. What is the ratio of the Value added (% of GDP) of Uganda in 1995 to that in 1998?
Your response must be concise. 0.79. What is the ratio of the Value added (% of GDP) of European Union in 1995 to that in 1999?
Your answer should be compact. 1.06. What is the ratio of the Value added (% of GDP) in Bulgaria in 1995 to that in 1999?
Offer a very short reply. 1.13. What is the ratio of the Value added (% of GDP) in Norway in 1995 to that in 1999?
Provide a short and direct response. 0.97. What is the ratio of the Value added (% of GDP) in Uganda in 1995 to that in 1999?
Your answer should be very brief. 0.72. What is the ratio of the Value added (% of GDP) in European Union in 1996 to that in 1997?
Provide a succinct answer. 1.01. What is the ratio of the Value added (% of GDP) in Bulgaria in 1996 to that in 1997?
Ensure brevity in your answer.  0.9. What is the ratio of the Value added (% of GDP) in Norway in 1996 to that in 1997?
Your answer should be compact. 0.98. What is the ratio of the Value added (% of GDP) in Uganda in 1996 to that in 1997?
Provide a succinct answer. 0.92. What is the ratio of the Value added (% of GDP) of European Union in 1996 to that in 1998?
Your answer should be compact. 1.02. What is the ratio of the Value added (% of GDP) of Bulgaria in 1996 to that in 1998?
Offer a terse response. 0.87. What is the ratio of the Value added (% of GDP) in Norway in 1996 to that in 1998?
Give a very brief answer. 1.12. What is the ratio of the Value added (% of GDP) of Uganda in 1996 to that in 1998?
Keep it short and to the point. 0.9. What is the ratio of the Value added (% of GDP) in European Union in 1996 to that in 1999?
Keep it short and to the point. 1.04. What is the ratio of the Value added (% of GDP) of Bulgaria in 1996 to that in 1999?
Your response must be concise. 0.85. What is the ratio of the Value added (% of GDP) in Norway in 1996 to that in 1999?
Your response must be concise. 1.05. What is the ratio of the Value added (% of GDP) of Uganda in 1996 to that in 1999?
Give a very brief answer. 0.82. What is the ratio of the Value added (% of GDP) in European Union in 1997 to that in 1998?
Your response must be concise. 1.01. What is the ratio of the Value added (% of GDP) in Bulgaria in 1997 to that in 1998?
Your response must be concise. 0.96. What is the ratio of the Value added (% of GDP) of Norway in 1997 to that in 1998?
Offer a very short reply. 1.14. What is the ratio of the Value added (% of GDP) of Uganda in 1997 to that in 1998?
Your response must be concise. 0.97. What is the ratio of the Value added (% of GDP) of European Union in 1997 to that in 1999?
Keep it short and to the point. 1.03. What is the ratio of the Value added (% of GDP) of Bulgaria in 1997 to that in 1999?
Offer a terse response. 0.94. What is the ratio of the Value added (% of GDP) in Norway in 1997 to that in 1999?
Provide a succinct answer. 1.06. What is the ratio of the Value added (% of GDP) of Uganda in 1997 to that in 1999?
Ensure brevity in your answer.  0.89. What is the ratio of the Value added (% of GDP) in European Union in 1998 to that in 1999?
Your response must be concise. 1.02. What is the ratio of the Value added (% of GDP) in Bulgaria in 1998 to that in 1999?
Offer a terse response. 0.98. What is the ratio of the Value added (% of GDP) in Norway in 1998 to that in 1999?
Ensure brevity in your answer.  0.94. What is the ratio of the Value added (% of GDP) of Uganda in 1998 to that in 1999?
Your answer should be compact. 0.92. What is the difference between the highest and the second highest Value added (% of GDP) in European Union?
Provide a succinct answer. 0.05. What is the difference between the highest and the second highest Value added (% of GDP) of Bulgaria?
Give a very brief answer. 2.41. What is the difference between the highest and the second highest Value added (% of GDP) of Norway?
Ensure brevity in your answer.  0.58. What is the difference between the highest and the second highest Value added (% of GDP) in Uganda?
Ensure brevity in your answer.  1.65. What is the difference between the highest and the lowest Value added (% of GDP) of European Union?
Provide a succinct answer. 1.67. What is the difference between the highest and the lowest Value added (% of GDP) in Bulgaria?
Give a very brief answer. 15.84. What is the difference between the highest and the lowest Value added (% of GDP) in Norway?
Offer a terse response. 4.87. What is the difference between the highest and the lowest Value added (% of GDP) of Uganda?
Keep it short and to the point. 6.63. 